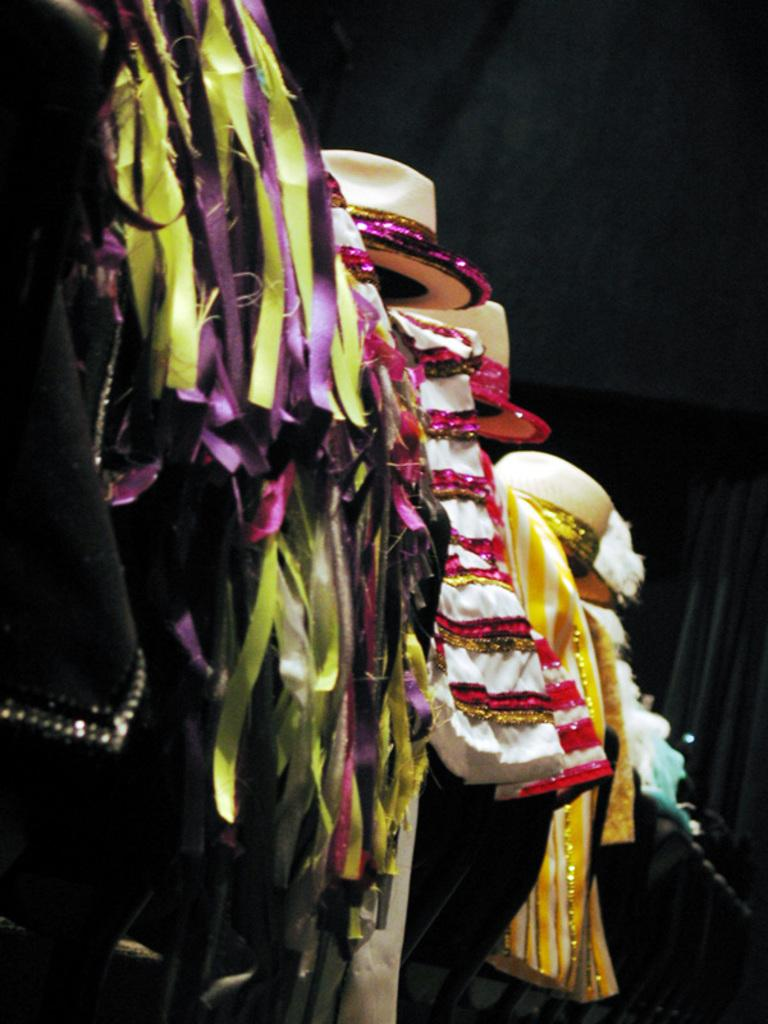What type of accessories are present in the image? There are hats in the image. What else can be seen in the image besides hats? There are clothes in the image. Can you describe the background of the image? The background of the image is dark. How many eyes can be seen on the girl in the image? There is no girl present in the image, so it is not possible to determine the number of eyes. 